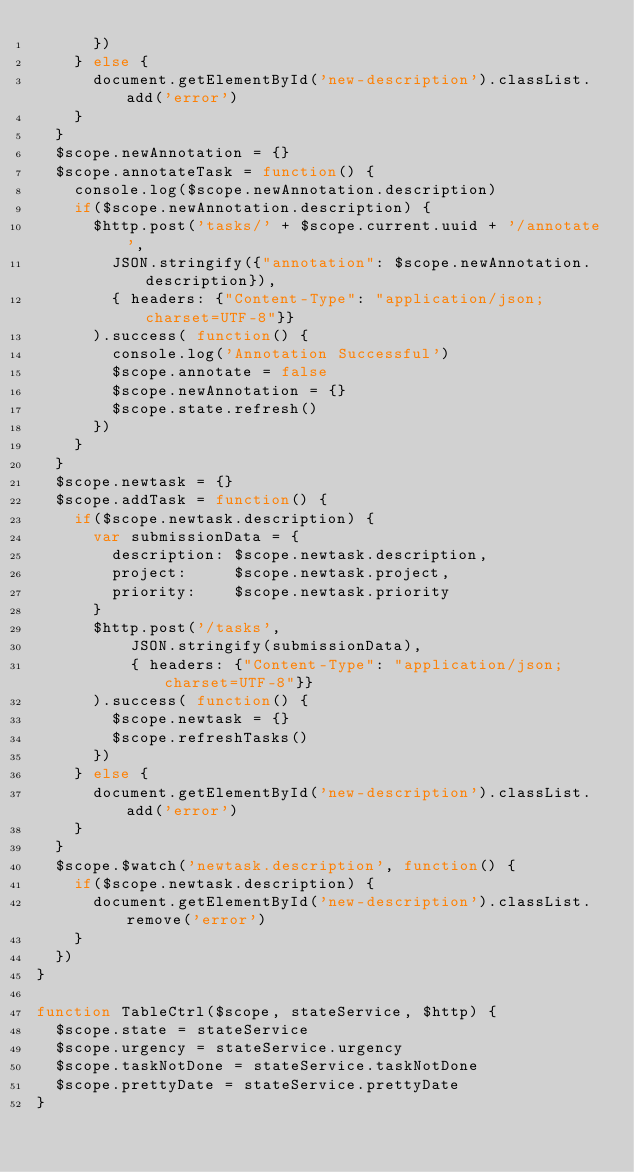Convert code to text. <code><loc_0><loc_0><loc_500><loc_500><_JavaScript_>      })
    } else {
      document.getElementById('new-description').classList.add('error')
    }
  }
  $scope.newAnnotation = {}
  $scope.annotateTask = function() {
    console.log($scope.newAnnotation.description)
    if($scope.newAnnotation.description) {
      $http.post('tasks/' + $scope.current.uuid + '/annotate',
        JSON.stringify({"annotation": $scope.newAnnotation.description}),
        { headers: {"Content-Type": "application/json; charset=UTF-8"}}
      ).success( function() {
        console.log('Annotation Successful')
        $scope.annotate = false
        $scope.newAnnotation = {}
        $scope.state.refresh()
      })
    }
  }
  $scope.newtask = {}
  $scope.addTask = function() {
    if($scope.newtask.description) {
      var submissionData = {
        description: $scope.newtask.description,
        project:     $scope.newtask.project,
        priority:    $scope.newtask.priority
      }
      $http.post('/tasks',
          JSON.stringify(submissionData),
          { headers: {"Content-Type": "application/json; charset=UTF-8"}}
      ).success( function() {
        $scope.newtask = {}
        $scope.refreshTasks()
      })
    } else {
      document.getElementById('new-description').classList.add('error')
    }
  }
  $scope.$watch('newtask.description', function() {
    if($scope.newtask.description) {
      document.getElementById('new-description').classList.remove('error')
    }
  })
}

function TableCtrl($scope, stateService, $http) {
  $scope.state = stateService
  $scope.urgency = stateService.urgency
  $scope.taskNotDone = stateService.taskNotDone
  $scope.prettyDate = stateService.prettyDate
}
</code> 